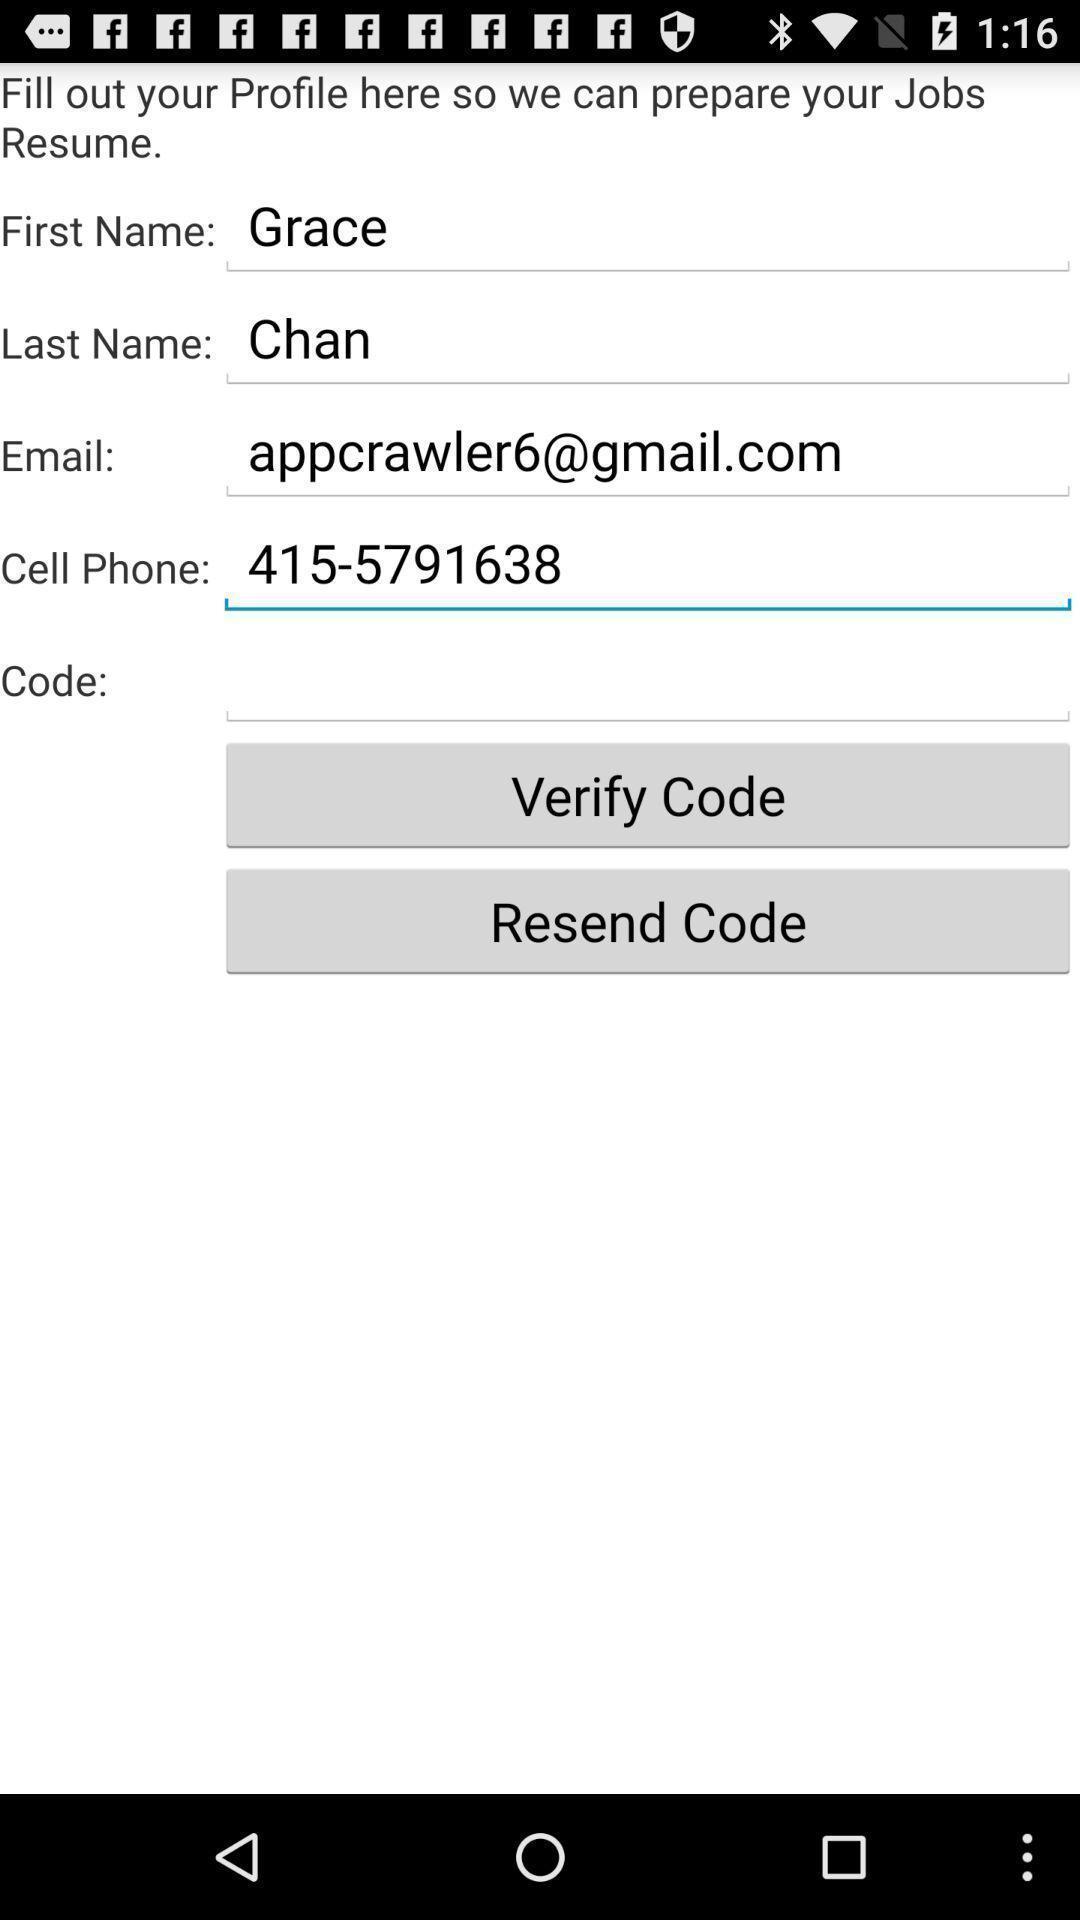Give me a narrative description of this picture. Screen shows multiple details in a social app. 